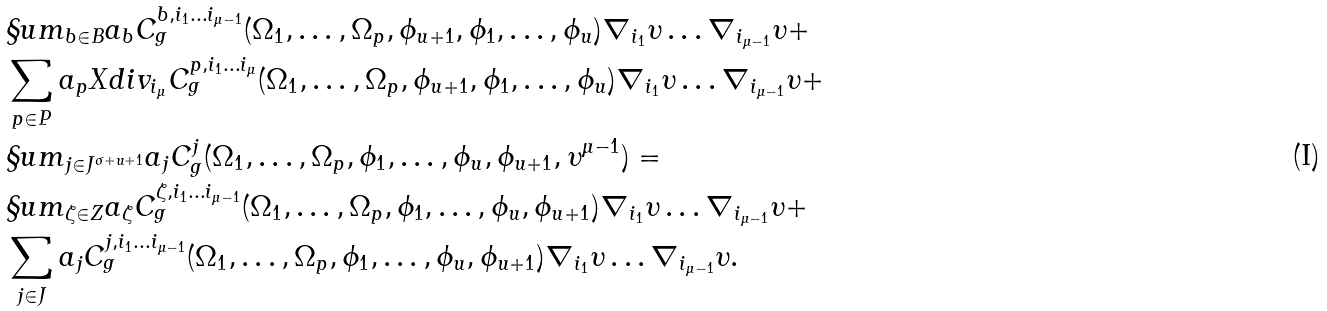<formula> <loc_0><loc_0><loc_500><loc_500>& \S u m _ { b \in B } a _ { b } C ^ { b , i _ { 1 } \dots i _ { \mu - 1 } } _ { g } ( \Omega _ { 1 } , \dots , \Omega _ { p } , \phi _ { u + 1 } , \phi _ { 1 } , \dots , \phi _ { u } ) \nabla _ { i _ { 1 } } \upsilon \dots \nabla _ { i _ { \mu - 1 } } \upsilon + \\ & \sum _ { p \in P } a _ { p } X d i v _ { i _ { \mu } } C ^ { p , i _ { 1 } \dots i _ { \mu } } _ { g } ( \Omega _ { 1 } , \dots , \Omega _ { p } , \phi _ { u + 1 } , \phi _ { 1 } , \dots , \phi _ { u } ) \nabla _ { i _ { 1 } } \upsilon \dots \nabla _ { i _ { \mu - 1 } } \upsilon + \\ & \S u m _ { j \in J ^ { \sigma + u + 1 } } a _ { j } C ^ { j } _ { g } ( \Omega _ { 1 } , \dots , \Omega _ { p } , \phi _ { 1 } , \dots , \phi _ { u } , \phi _ { u + 1 } , \upsilon ^ { \mu - 1 } ) = \\ & \S u m _ { \zeta \in Z } a _ { \zeta } C ^ { \zeta , i _ { 1 } \dots i _ { \mu - 1 } } _ { g } ( \Omega _ { 1 } , \dots , \Omega _ { p } , \phi _ { 1 } , \dots , \phi _ { u } , \phi _ { u + 1 } ) \nabla _ { i _ { 1 } } \upsilon \dots \nabla _ { i _ { \mu - 1 } } \upsilon + \\ & \sum _ { j \in J } a _ { j } C ^ { j , i _ { 1 } \dots i _ { \mu - 1 } } _ { g } ( \Omega _ { 1 } , \dots , \Omega _ { p } , \phi _ { 1 } , \dots , \phi _ { u } , \phi _ { u + 1 } ) \nabla _ { i _ { 1 } } \upsilon \dots \nabla _ { i _ { \mu - 1 } } \upsilon .</formula> 